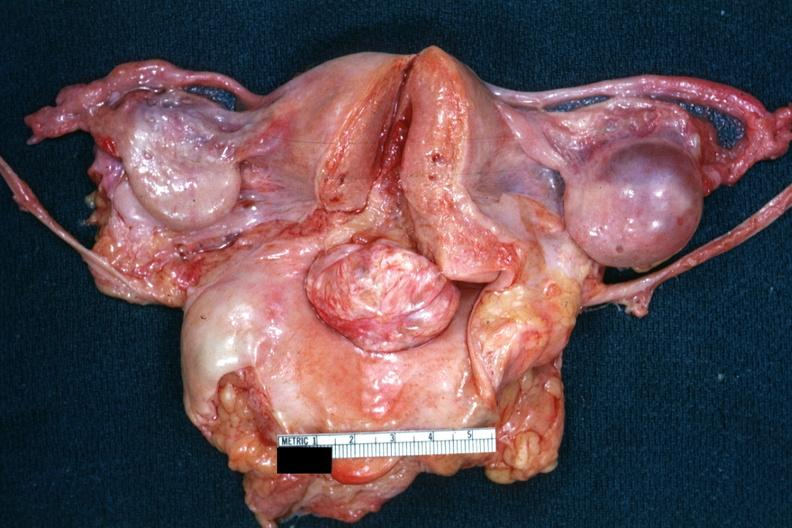what is present?
Answer the question using a single word or phrase. Cervical leiomyoma 